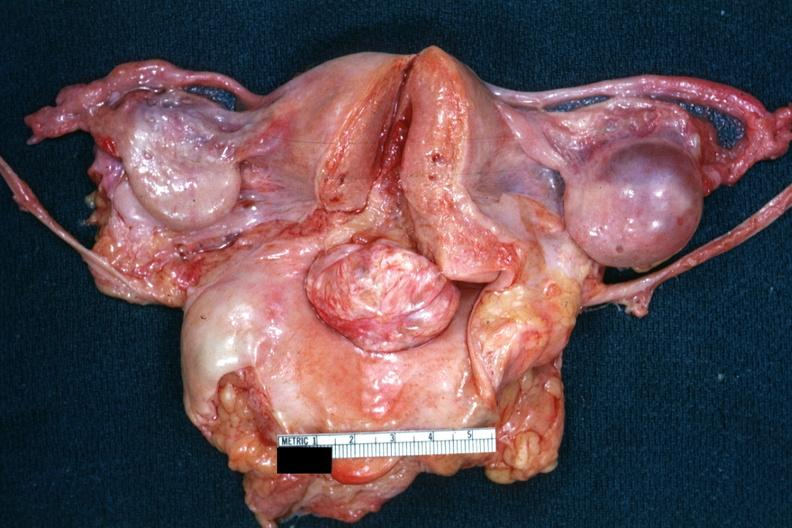what is present?
Answer the question using a single word or phrase. Cervical leiomyoma 